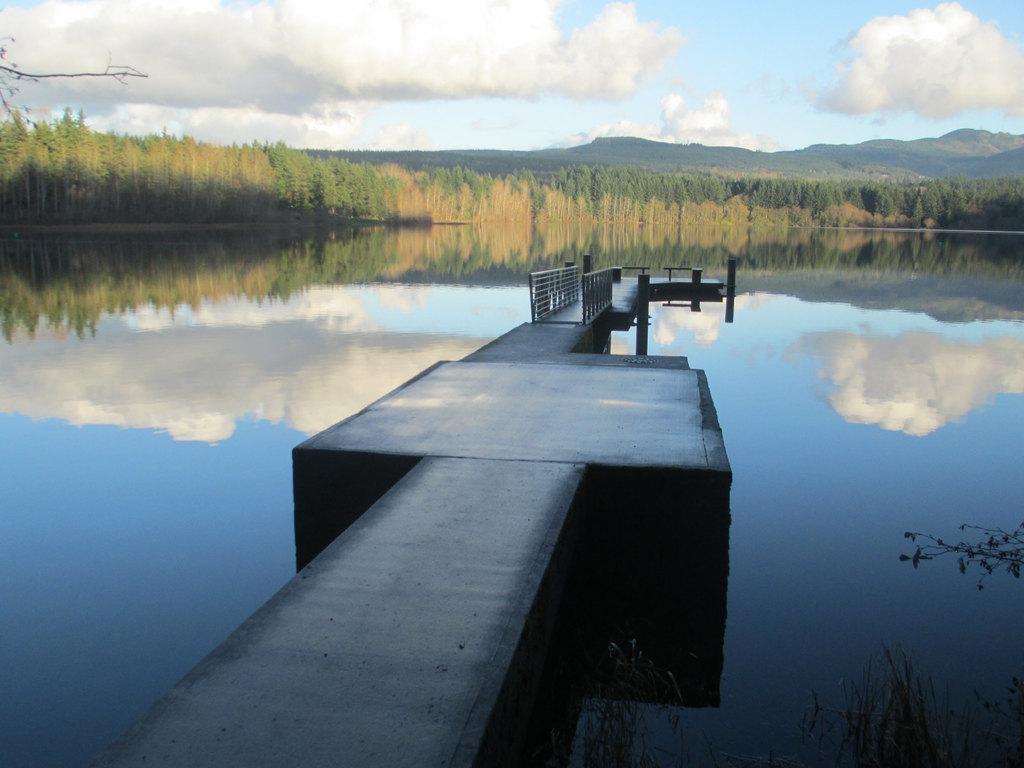Describe this image in one or two sentences. In this picture there is a wooden bridge. At the back there are mountains and trees. At the top there is sky and there are clouds. At the bottom there is water and there is reflection of sky and there is reflection of clouds on the water. 